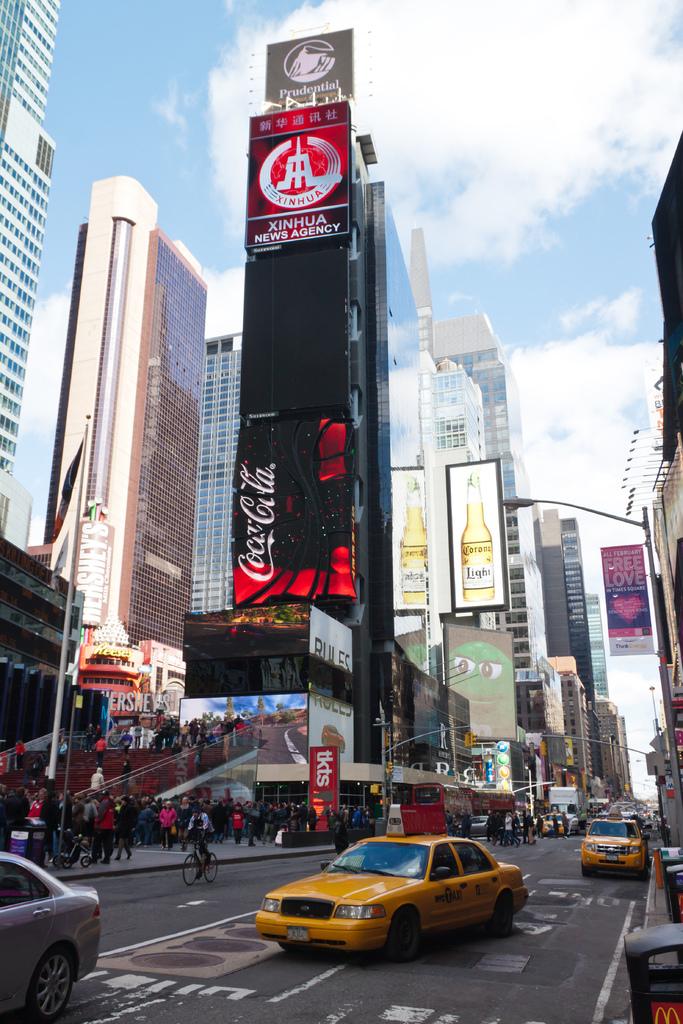What soda company is being advertised?
Your response must be concise. Coca cola. 